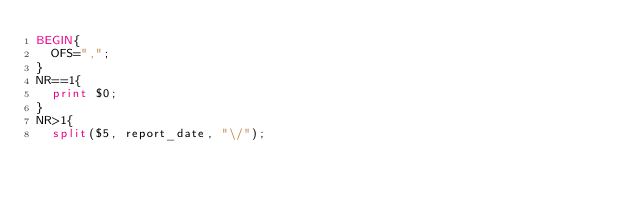<code> <loc_0><loc_0><loc_500><loc_500><_Awk_>BEGIN{
  OFS=",";
}
NR==1{
  print $0;
}
NR>1{
  split($5, report_date, "\/");</code> 